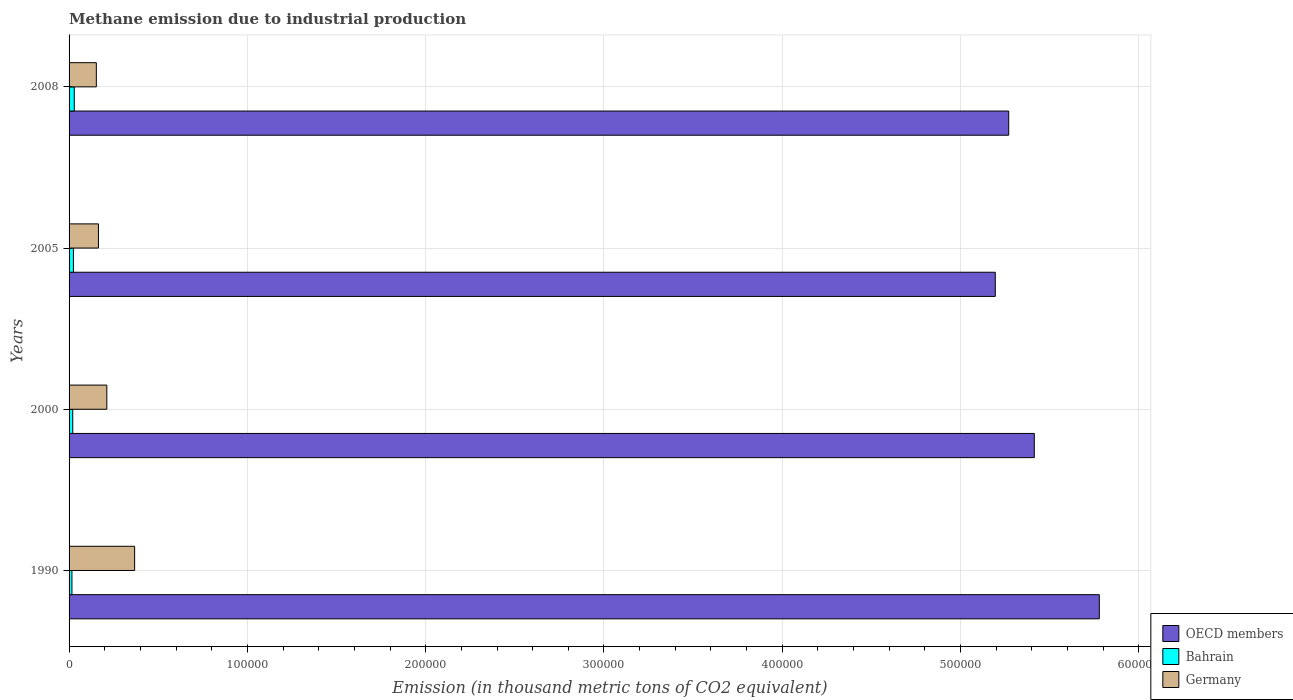How many different coloured bars are there?
Ensure brevity in your answer.  3. How many groups of bars are there?
Give a very brief answer. 4. Are the number of bars per tick equal to the number of legend labels?
Offer a very short reply. Yes. Are the number of bars on each tick of the Y-axis equal?
Provide a succinct answer. Yes. How many bars are there on the 2nd tick from the top?
Your answer should be very brief. 3. What is the label of the 3rd group of bars from the top?
Your response must be concise. 2000. What is the amount of methane emitted in OECD members in 2000?
Keep it short and to the point. 5.41e+05. Across all years, what is the maximum amount of methane emitted in OECD members?
Your answer should be compact. 5.78e+05. Across all years, what is the minimum amount of methane emitted in Bahrain?
Ensure brevity in your answer.  1607.3. In which year was the amount of methane emitted in OECD members maximum?
Offer a very short reply. 1990. In which year was the amount of methane emitted in Bahrain minimum?
Offer a terse response. 1990. What is the total amount of methane emitted in OECD members in the graph?
Offer a very short reply. 2.17e+06. What is the difference between the amount of methane emitted in Bahrain in 1990 and that in 2005?
Your answer should be compact. -843.3. What is the difference between the amount of methane emitted in Bahrain in 1990 and the amount of methane emitted in Germany in 2005?
Provide a short and direct response. -1.49e+04. What is the average amount of methane emitted in OECD members per year?
Give a very brief answer. 5.41e+05. In the year 2005, what is the difference between the amount of methane emitted in Bahrain and amount of methane emitted in Germany?
Your response must be concise. -1.40e+04. In how many years, is the amount of methane emitted in OECD members greater than 260000 thousand metric tons?
Make the answer very short. 4. What is the ratio of the amount of methane emitted in OECD members in 2000 to that in 2008?
Provide a short and direct response. 1.03. Is the difference between the amount of methane emitted in Bahrain in 2000 and 2008 greater than the difference between the amount of methane emitted in Germany in 2000 and 2008?
Your response must be concise. No. What is the difference between the highest and the second highest amount of methane emitted in OECD members?
Give a very brief answer. 3.65e+04. What is the difference between the highest and the lowest amount of methane emitted in Bahrain?
Your response must be concise. 1315.9. In how many years, is the amount of methane emitted in OECD members greater than the average amount of methane emitted in OECD members taken over all years?
Keep it short and to the point. 1. Is the sum of the amount of methane emitted in OECD members in 2000 and 2008 greater than the maximum amount of methane emitted in Germany across all years?
Make the answer very short. Yes. What does the 3rd bar from the bottom in 2000 represents?
Provide a short and direct response. Germany. Is it the case that in every year, the sum of the amount of methane emitted in Germany and amount of methane emitted in OECD members is greater than the amount of methane emitted in Bahrain?
Offer a very short reply. Yes. Are the values on the major ticks of X-axis written in scientific E-notation?
Offer a very short reply. No. Where does the legend appear in the graph?
Keep it short and to the point. Bottom right. How many legend labels are there?
Offer a terse response. 3. How are the legend labels stacked?
Your answer should be compact. Vertical. What is the title of the graph?
Offer a very short reply. Methane emission due to industrial production. Does "China" appear as one of the legend labels in the graph?
Make the answer very short. No. What is the label or title of the X-axis?
Provide a short and direct response. Emission (in thousand metric tons of CO2 equivalent). What is the Emission (in thousand metric tons of CO2 equivalent) of OECD members in 1990?
Give a very brief answer. 5.78e+05. What is the Emission (in thousand metric tons of CO2 equivalent) of Bahrain in 1990?
Ensure brevity in your answer.  1607.3. What is the Emission (in thousand metric tons of CO2 equivalent) in Germany in 1990?
Make the answer very short. 3.68e+04. What is the Emission (in thousand metric tons of CO2 equivalent) in OECD members in 2000?
Offer a terse response. 5.41e+05. What is the Emission (in thousand metric tons of CO2 equivalent) of Bahrain in 2000?
Offer a very short reply. 2050.3. What is the Emission (in thousand metric tons of CO2 equivalent) of Germany in 2000?
Give a very brief answer. 2.12e+04. What is the Emission (in thousand metric tons of CO2 equivalent) of OECD members in 2005?
Keep it short and to the point. 5.19e+05. What is the Emission (in thousand metric tons of CO2 equivalent) of Bahrain in 2005?
Your answer should be very brief. 2450.6. What is the Emission (in thousand metric tons of CO2 equivalent) of Germany in 2005?
Offer a terse response. 1.65e+04. What is the Emission (in thousand metric tons of CO2 equivalent) in OECD members in 2008?
Provide a succinct answer. 5.27e+05. What is the Emission (in thousand metric tons of CO2 equivalent) in Bahrain in 2008?
Your answer should be very brief. 2923.2. What is the Emission (in thousand metric tons of CO2 equivalent) of Germany in 2008?
Your answer should be very brief. 1.53e+04. Across all years, what is the maximum Emission (in thousand metric tons of CO2 equivalent) of OECD members?
Your answer should be compact. 5.78e+05. Across all years, what is the maximum Emission (in thousand metric tons of CO2 equivalent) in Bahrain?
Provide a succinct answer. 2923.2. Across all years, what is the maximum Emission (in thousand metric tons of CO2 equivalent) of Germany?
Ensure brevity in your answer.  3.68e+04. Across all years, what is the minimum Emission (in thousand metric tons of CO2 equivalent) in OECD members?
Your answer should be compact. 5.19e+05. Across all years, what is the minimum Emission (in thousand metric tons of CO2 equivalent) of Bahrain?
Give a very brief answer. 1607.3. Across all years, what is the minimum Emission (in thousand metric tons of CO2 equivalent) in Germany?
Keep it short and to the point. 1.53e+04. What is the total Emission (in thousand metric tons of CO2 equivalent) of OECD members in the graph?
Keep it short and to the point. 2.17e+06. What is the total Emission (in thousand metric tons of CO2 equivalent) in Bahrain in the graph?
Give a very brief answer. 9031.4. What is the total Emission (in thousand metric tons of CO2 equivalent) of Germany in the graph?
Make the answer very short. 8.97e+04. What is the difference between the Emission (in thousand metric tons of CO2 equivalent) in OECD members in 1990 and that in 2000?
Your answer should be very brief. 3.65e+04. What is the difference between the Emission (in thousand metric tons of CO2 equivalent) in Bahrain in 1990 and that in 2000?
Offer a terse response. -443. What is the difference between the Emission (in thousand metric tons of CO2 equivalent) of Germany in 1990 and that in 2000?
Your answer should be very brief. 1.56e+04. What is the difference between the Emission (in thousand metric tons of CO2 equivalent) of OECD members in 1990 and that in 2005?
Make the answer very short. 5.83e+04. What is the difference between the Emission (in thousand metric tons of CO2 equivalent) of Bahrain in 1990 and that in 2005?
Keep it short and to the point. -843.3. What is the difference between the Emission (in thousand metric tons of CO2 equivalent) in Germany in 1990 and that in 2005?
Your response must be concise. 2.03e+04. What is the difference between the Emission (in thousand metric tons of CO2 equivalent) in OECD members in 1990 and that in 2008?
Keep it short and to the point. 5.08e+04. What is the difference between the Emission (in thousand metric tons of CO2 equivalent) in Bahrain in 1990 and that in 2008?
Your response must be concise. -1315.9. What is the difference between the Emission (in thousand metric tons of CO2 equivalent) of Germany in 1990 and that in 2008?
Your answer should be very brief. 2.15e+04. What is the difference between the Emission (in thousand metric tons of CO2 equivalent) in OECD members in 2000 and that in 2005?
Your answer should be very brief. 2.19e+04. What is the difference between the Emission (in thousand metric tons of CO2 equivalent) of Bahrain in 2000 and that in 2005?
Your response must be concise. -400.3. What is the difference between the Emission (in thousand metric tons of CO2 equivalent) in Germany in 2000 and that in 2005?
Your answer should be very brief. 4692.6. What is the difference between the Emission (in thousand metric tons of CO2 equivalent) of OECD members in 2000 and that in 2008?
Offer a terse response. 1.43e+04. What is the difference between the Emission (in thousand metric tons of CO2 equivalent) in Bahrain in 2000 and that in 2008?
Ensure brevity in your answer.  -872.9. What is the difference between the Emission (in thousand metric tons of CO2 equivalent) of Germany in 2000 and that in 2008?
Ensure brevity in your answer.  5882.8. What is the difference between the Emission (in thousand metric tons of CO2 equivalent) of OECD members in 2005 and that in 2008?
Your response must be concise. -7540.4. What is the difference between the Emission (in thousand metric tons of CO2 equivalent) in Bahrain in 2005 and that in 2008?
Provide a short and direct response. -472.6. What is the difference between the Emission (in thousand metric tons of CO2 equivalent) of Germany in 2005 and that in 2008?
Give a very brief answer. 1190.2. What is the difference between the Emission (in thousand metric tons of CO2 equivalent) in OECD members in 1990 and the Emission (in thousand metric tons of CO2 equivalent) in Bahrain in 2000?
Keep it short and to the point. 5.76e+05. What is the difference between the Emission (in thousand metric tons of CO2 equivalent) of OECD members in 1990 and the Emission (in thousand metric tons of CO2 equivalent) of Germany in 2000?
Your response must be concise. 5.57e+05. What is the difference between the Emission (in thousand metric tons of CO2 equivalent) of Bahrain in 1990 and the Emission (in thousand metric tons of CO2 equivalent) of Germany in 2000?
Your response must be concise. -1.96e+04. What is the difference between the Emission (in thousand metric tons of CO2 equivalent) of OECD members in 1990 and the Emission (in thousand metric tons of CO2 equivalent) of Bahrain in 2005?
Make the answer very short. 5.75e+05. What is the difference between the Emission (in thousand metric tons of CO2 equivalent) in OECD members in 1990 and the Emission (in thousand metric tons of CO2 equivalent) in Germany in 2005?
Ensure brevity in your answer.  5.61e+05. What is the difference between the Emission (in thousand metric tons of CO2 equivalent) of Bahrain in 1990 and the Emission (in thousand metric tons of CO2 equivalent) of Germany in 2005?
Provide a succinct answer. -1.49e+04. What is the difference between the Emission (in thousand metric tons of CO2 equivalent) of OECD members in 1990 and the Emission (in thousand metric tons of CO2 equivalent) of Bahrain in 2008?
Your answer should be very brief. 5.75e+05. What is the difference between the Emission (in thousand metric tons of CO2 equivalent) of OECD members in 1990 and the Emission (in thousand metric tons of CO2 equivalent) of Germany in 2008?
Your response must be concise. 5.63e+05. What is the difference between the Emission (in thousand metric tons of CO2 equivalent) of Bahrain in 1990 and the Emission (in thousand metric tons of CO2 equivalent) of Germany in 2008?
Offer a very short reply. -1.37e+04. What is the difference between the Emission (in thousand metric tons of CO2 equivalent) in OECD members in 2000 and the Emission (in thousand metric tons of CO2 equivalent) in Bahrain in 2005?
Give a very brief answer. 5.39e+05. What is the difference between the Emission (in thousand metric tons of CO2 equivalent) in OECD members in 2000 and the Emission (in thousand metric tons of CO2 equivalent) in Germany in 2005?
Provide a short and direct response. 5.25e+05. What is the difference between the Emission (in thousand metric tons of CO2 equivalent) in Bahrain in 2000 and the Emission (in thousand metric tons of CO2 equivalent) in Germany in 2005?
Ensure brevity in your answer.  -1.44e+04. What is the difference between the Emission (in thousand metric tons of CO2 equivalent) of OECD members in 2000 and the Emission (in thousand metric tons of CO2 equivalent) of Bahrain in 2008?
Ensure brevity in your answer.  5.38e+05. What is the difference between the Emission (in thousand metric tons of CO2 equivalent) in OECD members in 2000 and the Emission (in thousand metric tons of CO2 equivalent) in Germany in 2008?
Make the answer very short. 5.26e+05. What is the difference between the Emission (in thousand metric tons of CO2 equivalent) in Bahrain in 2000 and the Emission (in thousand metric tons of CO2 equivalent) in Germany in 2008?
Offer a very short reply. -1.32e+04. What is the difference between the Emission (in thousand metric tons of CO2 equivalent) in OECD members in 2005 and the Emission (in thousand metric tons of CO2 equivalent) in Bahrain in 2008?
Keep it short and to the point. 5.17e+05. What is the difference between the Emission (in thousand metric tons of CO2 equivalent) of OECD members in 2005 and the Emission (in thousand metric tons of CO2 equivalent) of Germany in 2008?
Provide a short and direct response. 5.04e+05. What is the difference between the Emission (in thousand metric tons of CO2 equivalent) in Bahrain in 2005 and the Emission (in thousand metric tons of CO2 equivalent) in Germany in 2008?
Keep it short and to the point. -1.28e+04. What is the average Emission (in thousand metric tons of CO2 equivalent) in OECD members per year?
Offer a very short reply. 5.41e+05. What is the average Emission (in thousand metric tons of CO2 equivalent) in Bahrain per year?
Provide a succinct answer. 2257.85. What is the average Emission (in thousand metric tons of CO2 equivalent) of Germany per year?
Give a very brief answer. 2.24e+04. In the year 1990, what is the difference between the Emission (in thousand metric tons of CO2 equivalent) of OECD members and Emission (in thousand metric tons of CO2 equivalent) of Bahrain?
Your answer should be very brief. 5.76e+05. In the year 1990, what is the difference between the Emission (in thousand metric tons of CO2 equivalent) of OECD members and Emission (in thousand metric tons of CO2 equivalent) of Germany?
Give a very brief answer. 5.41e+05. In the year 1990, what is the difference between the Emission (in thousand metric tons of CO2 equivalent) of Bahrain and Emission (in thousand metric tons of CO2 equivalent) of Germany?
Provide a succinct answer. -3.52e+04. In the year 2000, what is the difference between the Emission (in thousand metric tons of CO2 equivalent) of OECD members and Emission (in thousand metric tons of CO2 equivalent) of Bahrain?
Ensure brevity in your answer.  5.39e+05. In the year 2000, what is the difference between the Emission (in thousand metric tons of CO2 equivalent) in OECD members and Emission (in thousand metric tons of CO2 equivalent) in Germany?
Your answer should be compact. 5.20e+05. In the year 2000, what is the difference between the Emission (in thousand metric tons of CO2 equivalent) in Bahrain and Emission (in thousand metric tons of CO2 equivalent) in Germany?
Offer a very short reply. -1.91e+04. In the year 2005, what is the difference between the Emission (in thousand metric tons of CO2 equivalent) in OECD members and Emission (in thousand metric tons of CO2 equivalent) in Bahrain?
Your answer should be compact. 5.17e+05. In the year 2005, what is the difference between the Emission (in thousand metric tons of CO2 equivalent) of OECD members and Emission (in thousand metric tons of CO2 equivalent) of Germany?
Your answer should be very brief. 5.03e+05. In the year 2005, what is the difference between the Emission (in thousand metric tons of CO2 equivalent) of Bahrain and Emission (in thousand metric tons of CO2 equivalent) of Germany?
Your response must be concise. -1.40e+04. In the year 2008, what is the difference between the Emission (in thousand metric tons of CO2 equivalent) in OECD members and Emission (in thousand metric tons of CO2 equivalent) in Bahrain?
Provide a succinct answer. 5.24e+05. In the year 2008, what is the difference between the Emission (in thousand metric tons of CO2 equivalent) in OECD members and Emission (in thousand metric tons of CO2 equivalent) in Germany?
Keep it short and to the point. 5.12e+05. In the year 2008, what is the difference between the Emission (in thousand metric tons of CO2 equivalent) in Bahrain and Emission (in thousand metric tons of CO2 equivalent) in Germany?
Provide a succinct answer. -1.24e+04. What is the ratio of the Emission (in thousand metric tons of CO2 equivalent) of OECD members in 1990 to that in 2000?
Your answer should be compact. 1.07. What is the ratio of the Emission (in thousand metric tons of CO2 equivalent) in Bahrain in 1990 to that in 2000?
Provide a succinct answer. 0.78. What is the ratio of the Emission (in thousand metric tons of CO2 equivalent) of Germany in 1990 to that in 2000?
Your response must be concise. 1.74. What is the ratio of the Emission (in thousand metric tons of CO2 equivalent) in OECD members in 1990 to that in 2005?
Give a very brief answer. 1.11. What is the ratio of the Emission (in thousand metric tons of CO2 equivalent) in Bahrain in 1990 to that in 2005?
Give a very brief answer. 0.66. What is the ratio of the Emission (in thousand metric tons of CO2 equivalent) of Germany in 1990 to that in 2005?
Provide a succinct answer. 2.23. What is the ratio of the Emission (in thousand metric tons of CO2 equivalent) in OECD members in 1990 to that in 2008?
Your answer should be very brief. 1.1. What is the ratio of the Emission (in thousand metric tons of CO2 equivalent) in Bahrain in 1990 to that in 2008?
Give a very brief answer. 0.55. What is the ratio of the Emission (in thousand metric tons of CO2 equivalent) of Germany in 1990 to that in 2008?
Your answer should be compact. 2.4. What is the ratio of the Emission (in thousand metric tons of CO2 equivalent) of OECD members in 2000 to that in 2005?
Provide a succinct answer. 1.04. What is the ratio of the Emission (in thousand metric tons of CO2 equivalent) of Bahrain in 2000 to that in 2005?
Provide a succinct answer. 0.84. What is the ratio of the Emission (in thousand metric tons of CO2 equivalent) in Germany in 2000 to that in 2005?
Offer a terse response. 1.28. What is the ratio of the Emission (in thousand metric tons of CO2 equivalent) in OECD members in 2000 to that in 2008?
Make the answer very short. 1.03. What is the ratio of the Emission (in thousand metric tons of CO2 equivalent) in Bahrain in 2000 to that in 2008?
Provide a short and direct response. 0.7. What is the ratio of the Emission (in thousand metric tons of CO2 equivalent) in Germany in 2000 to that in 2008?
Provide a succinct answer. 1.38. What is the ratio of the Emission (in thousand metric tons of CO2 equivalent) of OECD members in 2005 to that in 2008?
Give a very brief answer. 0.99. What is the ratio of the Emission (in thousand metric tons of CO2 equivalent) in Bahrain in 2005 to that in 2008?
Your response must be concise. 0.84. What is the ratio of the Emission (in thousand metric tons of CO2 equivalent) in Germany in 2005 to that in 2008?
Offer a very short reply. 1.08. What is the difference between the highest and the second highest Emission (in thousand metric tons of CO2 equivalent) of OECD members?
Give a very brief answer. 3.65e+04. What is the difference between the highest and the second highest Emission (in thousand metric tons of CO2 equivalent) in Bahrain?
Offer a terse response. 472.6. What is the difference between the highest and the second highest Emission (in thousand metric tons of CO2 equivalent) in Germany?
Offer a very short reply. 1.56e+04. What is the difference between the highest and the lowest Emission (in thousand metric tons of CO2 equivalent) in OECD members?
Make the answer very short. 5.83e+04. What is the difference between the highest and the lowest Emission (in thousand metric tons of CO2 equivalent) in Bahrain?
Your answer should be compact. 1315.9. What is the difference between the highest and the lowest Emission (in thousand metric tons of CO2 equivalent) of Germany?
Give a very brief answer. 2.15e+04. 